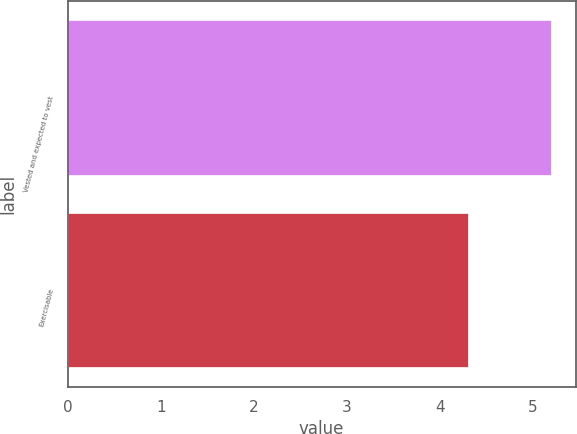Convert chart. <chart><loc_0><loc_0><loc_500><loc_500><bar_chart><fcel>Vested and expected to vest<fcel>Exercisable<nl><fcel>5.2<fcel>4.3<nl></chart> 